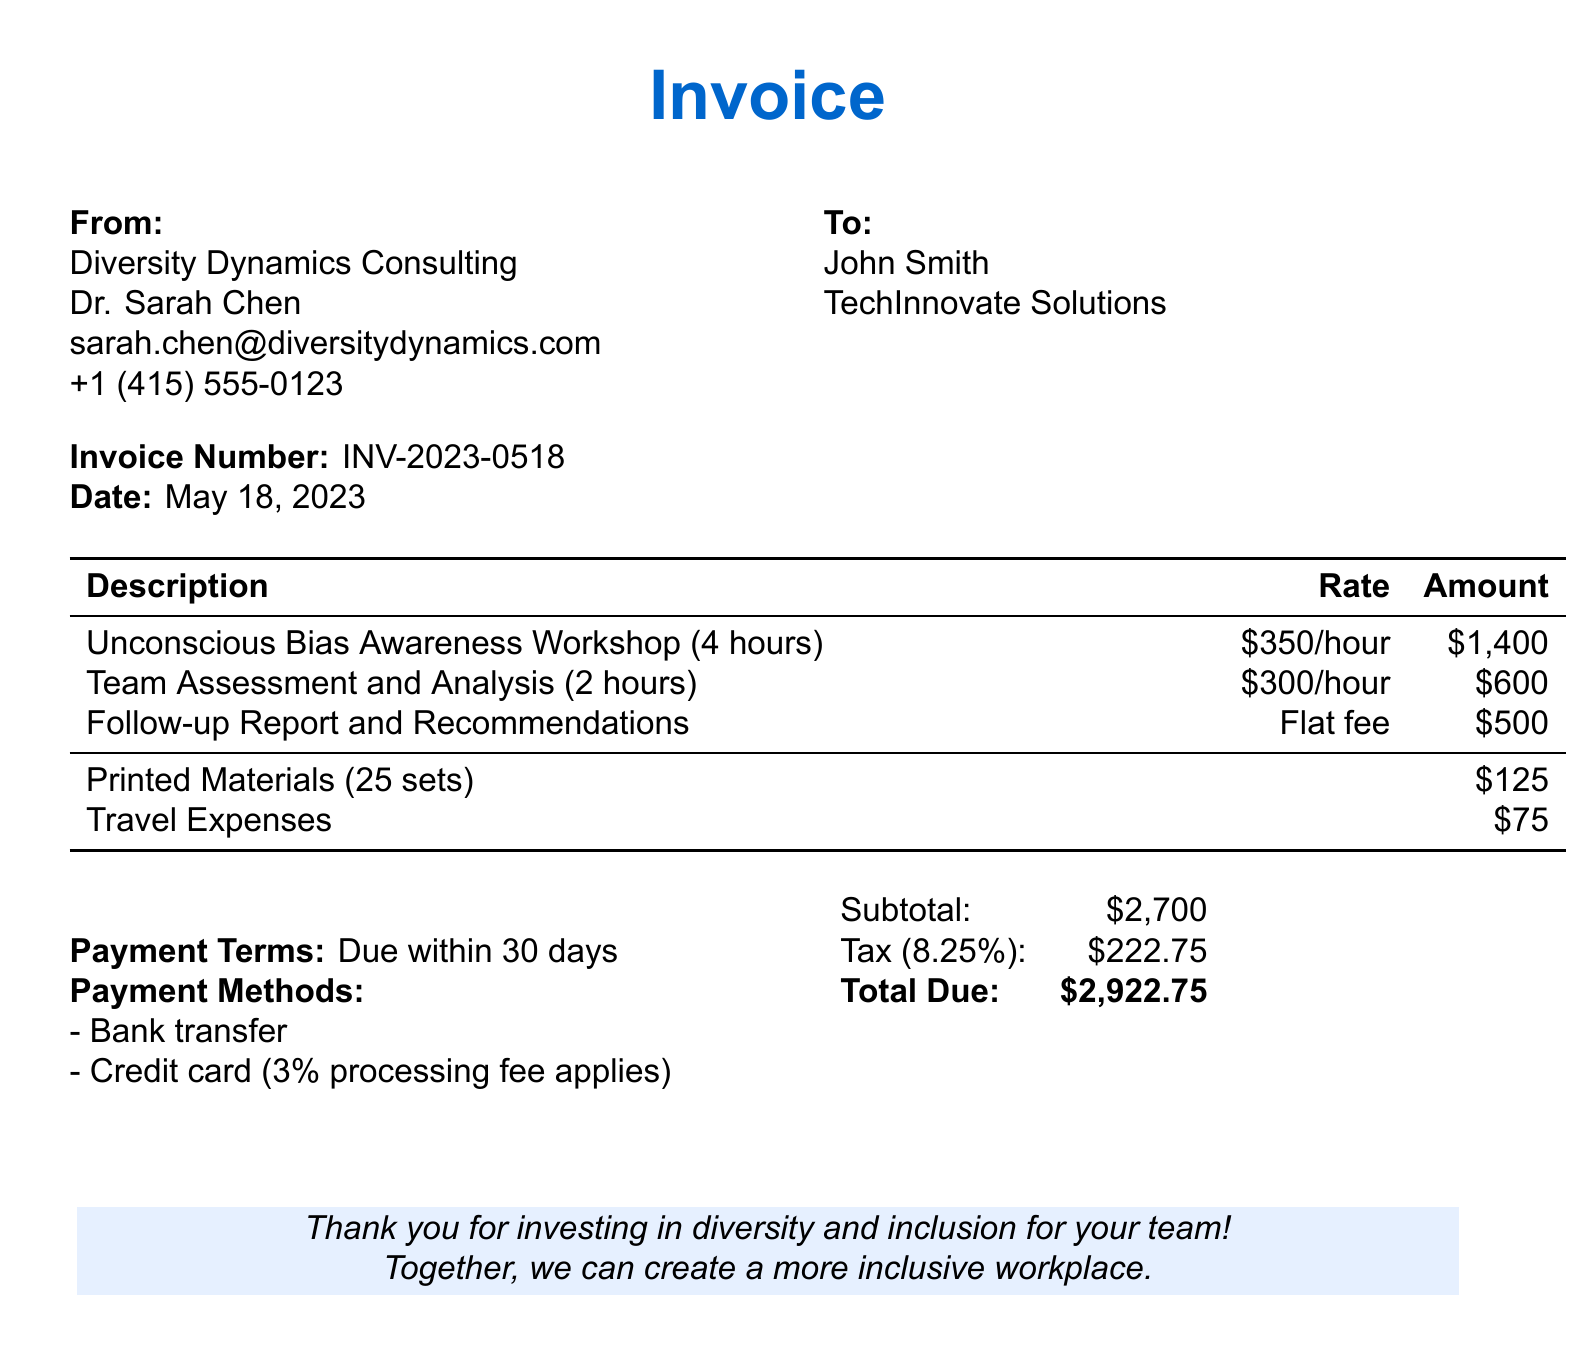What is the invoice number? The invoice number is located in the document and is used for tracking purposes.
Answer: INV-2023-0518 What is the hourly rate for the Unconscious Bias Awareness Workshop? The hourly rate for this workshop is specified in the service description.
Answer: $350/hour How many hours is the Team Assessment and Analysis billed for? The number of hours is stated right next to the description of the service.
Answer: 2 hours What is the total amount due on the invoice? The total due is calculated by adding the subtotal and tax, and is stated clearly at the end of the document.
Answer: $2,922.75 What is the flat fee for the Follow-up Report and Recommendations? The fee for this service is mentioned in the amount column of the services provided.
Answer: $500 Who is the consultant conducting the bias awareness sessions? The name of the consultant is at the top of the document under the 'From' section.
Answer: Dr. Sarah Chen What is included in the printed materials charge? The number of sets and type of materials are implied in the printed materials charge line.
Answer: 25 sets What is the payment term stated in the document? This term specifies when payment for the services is due and can be found in the bottom section.
Answer: Due within 30 days What is the tax rate applied to the invoice? The tax rate is indicated next to the calculation of tax in the monetary summary.
Answer: 8.25% 